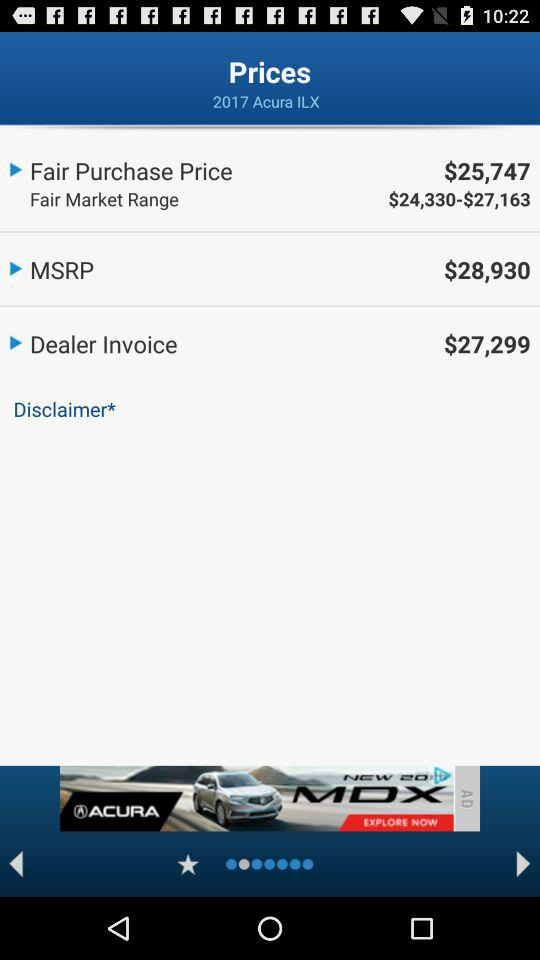What is the dealer invoice price of the "2017 Acura ILX"? The dealer invoice is $27,299. 